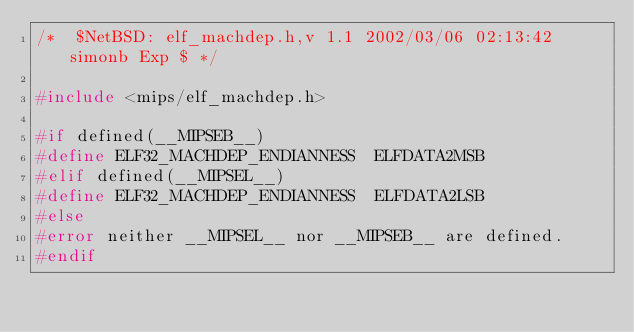<code> <loc_0><loc_0><loc_500><loc_500><_C_>/*	$NetBSD: elf_machdep.h,v 1.1 2002/03/06 02:13:42 simonb Exp $	*/

#include <mips/elf_machdep.h>

#if defined(__MIPSEB__)
#define	ELF32_MACHDEP_ENDIANNESS	ELFDATA2MSB
#elif defined(__MIPSEL__)
#define	ELF32_MACHDEP_ENDIANNESS	ELFDATA2LSB
#else
#error neither __MIPSEL__ nor __MIPSEB__ are defined.
#endif
</code> 